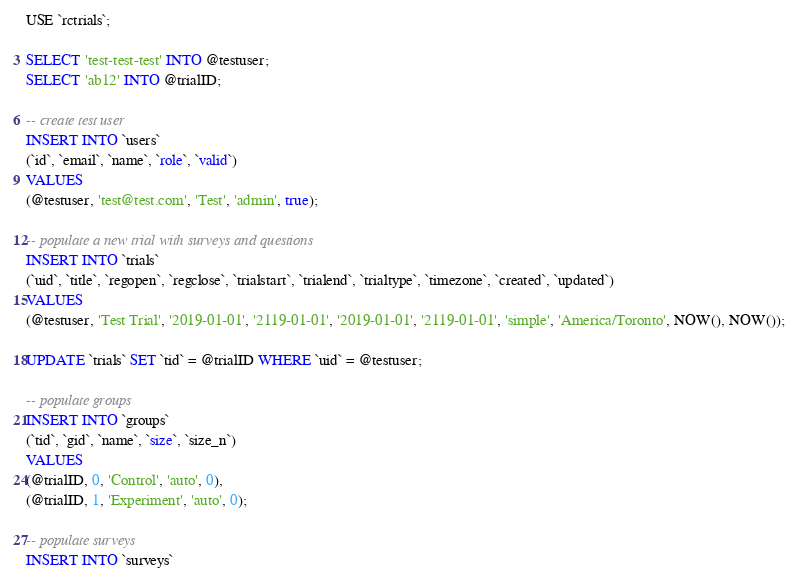<code> <loc_0><loc_0><loc_500><loc_500><_SQL_>USE `rctrials`;

SELECT 'test-test-test' INTO @testuser;
SELECT 'ab12' INTO @trialID;

-- create test user
INSERT INTO `users`
(`id`, `email`, `name`, `role`, `valid`)
VALUES
(@testuser, 'test@test.com', 'Test', 'admin', true);

-- populate a new trial with surveys and questions
INSERT INTO `trials`
(`uid`, `title`, `regopen`, `regclose`, `trialstart`, `trialend`, `trialtype`, `timezone`, `created`, `updated`)
VALUES
(@testuser, 'Test Trial', '2019-01-01', '2119-01-01', '2019-01-01', '2119-01-01', 'simple', 'America/Toronto', NOW(), NOW());

UPDATE `trials` SET `tid` = @trialID WHERE `uid` = @testuser;

-- populate groups
INSERT INTO `groups`
(`tid`, `gid`, `name`, `size`, `size_n`)
VALUES
(@trialID, 0, 'Control', 'auto', 0),
(@trialID, 1, 'Experiment', 'auto', 0);

-- populate surveys
INSERT INTO `surveys`</code> 